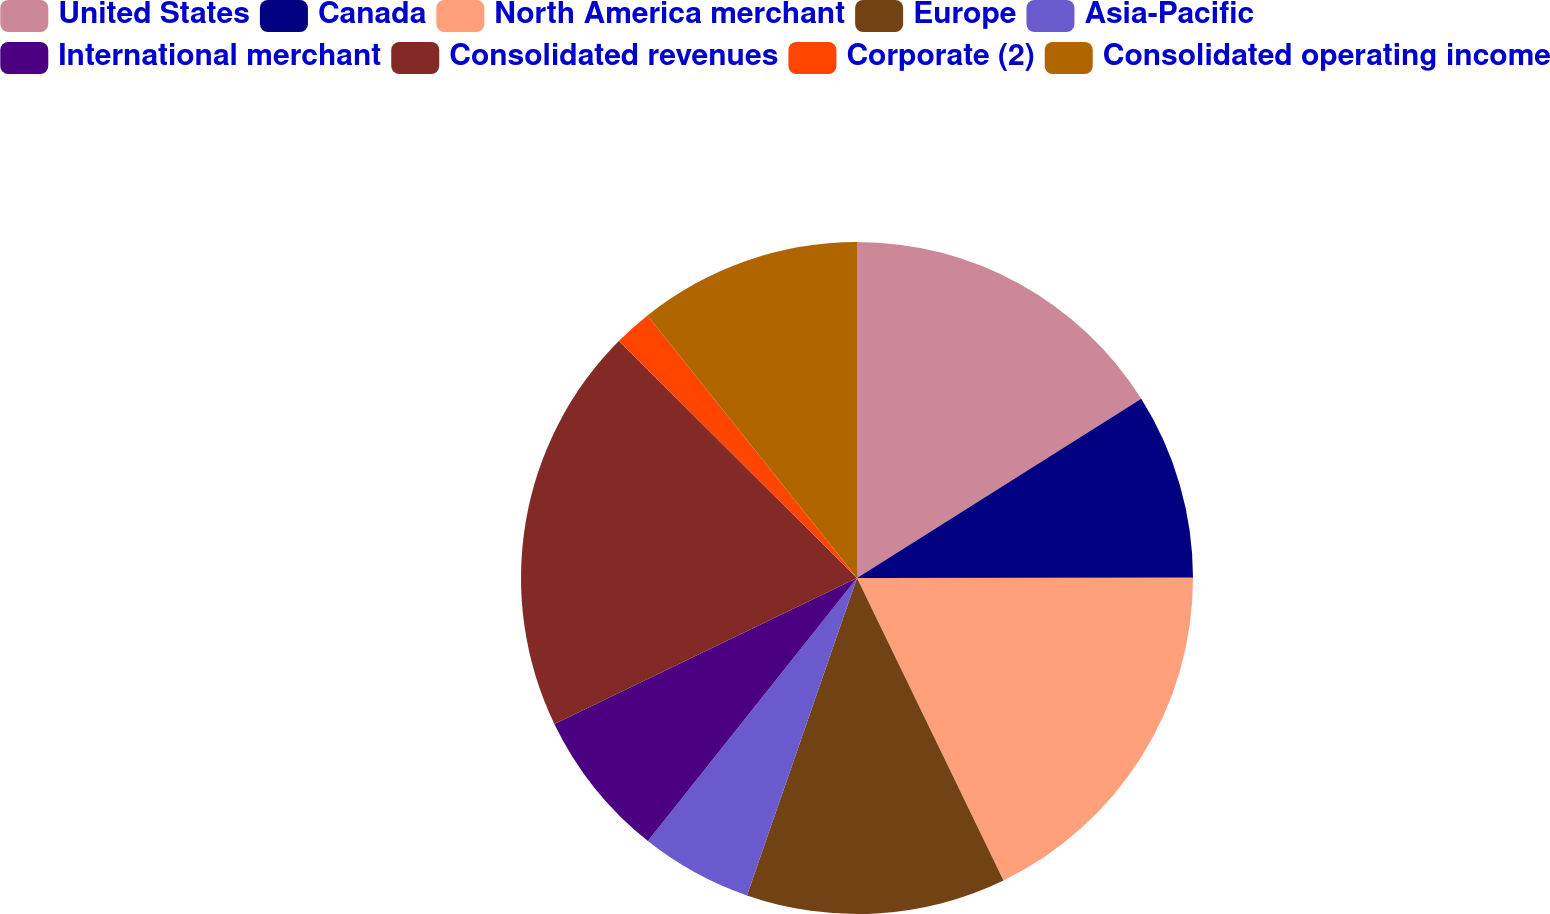Convert chart. <chart><loc_0><loc_0><loc_500><loc_500><pie_chart><fcel>United States<fcel>Canada<fcel>North America merchant<fcel>Europe<fcel>Asia-Pacific<fcel>International merchant<fcel>Consolidated revenues<fcel>Corporate (2)<fcel>Consolidated operating income<nl><fcel>16.05%<fcel>8.94%<fcel>17.83%<fcel>12.49%<fcel>5.38%<fcel>7.16%<fcel>19.61%<fcel>1.82%<fcel>10.72%<nl></chart> 